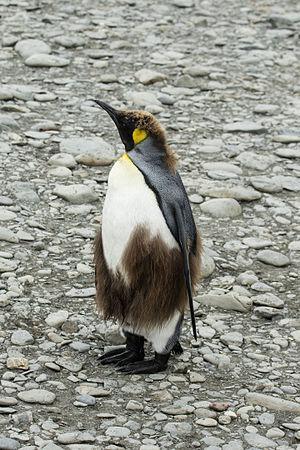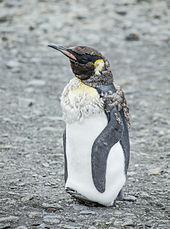The first image is the image on the left, the second image is the image on the right. Analyze the images presented: Is the assertion "There is exactly one animal in the image on the left." valid? Answer yes or no. Yes. The first image is the image on the left, the second image is the image on the right. Analyze the images presented: Is the assertion "At least one of the images show only one penguin." valid? Answer yes or no. Yes. 